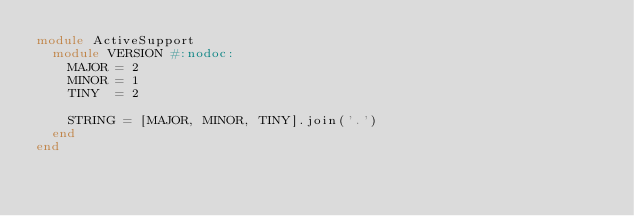<code> <loc_0><loc_0><loc_500><loc_500><_Ruby_>module ActiveSupport
  module VERSION #:nodoc:
    MAJOR = 2
    MINOR = 1
    TINY  = 2

    STRING = [MAJOR, MINOR, TINY].join('.')
  end
end
</code> 